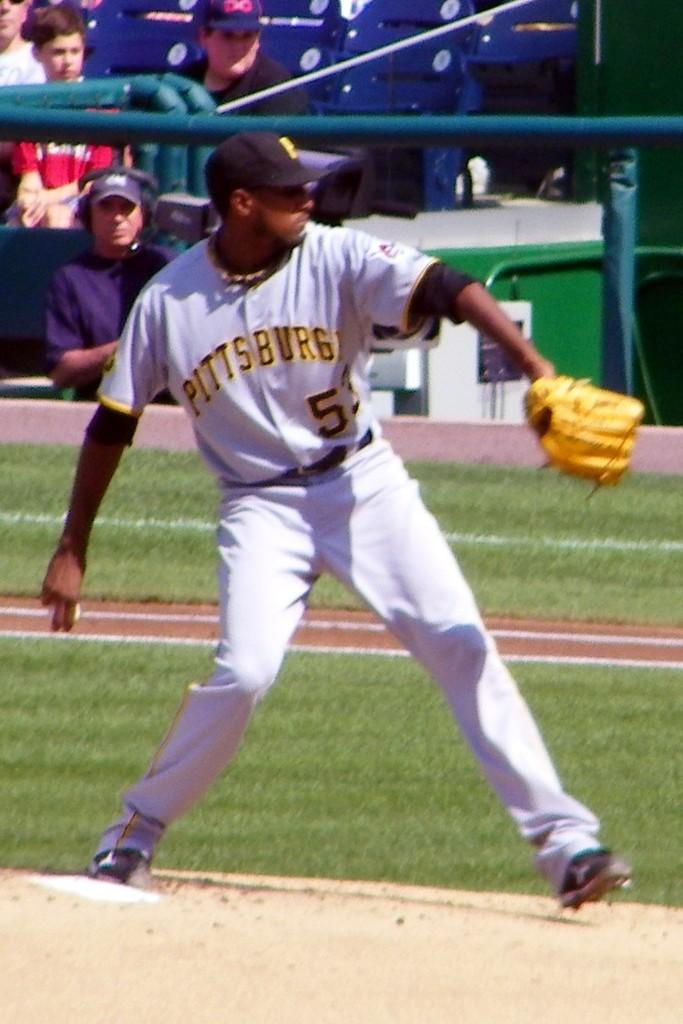<image>
Offer a succinct explanation of the picture presented. A Pittsburgh Baseball Player prepares to throw the ball. 